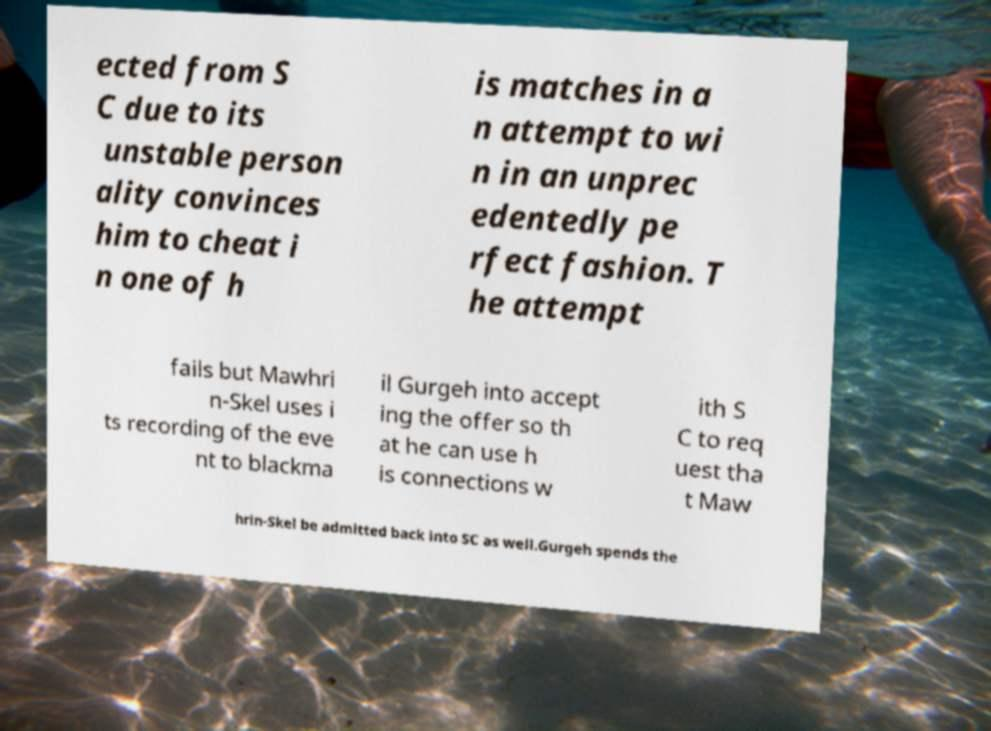Can you read and provide the text displayed in the image?This photo seems to have some interesting text. Can you extract and type it out for me? ected from S C due to its unstable person ality convinces him to cheat i n one of h is matches in a n attempt to wi n in an unprec edentedly pe rfect fashion. T he attempt fails but Mawhri n-Skel uses i ts recording of the eve nt to blackma il Gurgeh into accept ing the offer so th at he can use h is connections w ith S C to req uest tha t Maw hrin-Skel be admitted back into SC as well.Gurgeh spends the 